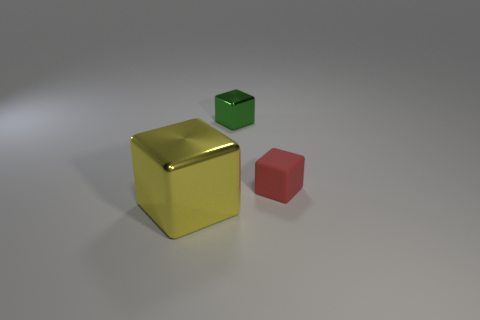Is there any other thing that has the same material as the red object?
Provide a short and direct response. No. What shape is the shiny object behind the object that is in front of the tiny red cube?
Give a very brief answer. Cube. The small metal object is what color?
Your answer should be compact. Green. Is there a tiny purple sphere?
Your answer should be very brief. No. There is a big yellow shiny object; are there any blocks behind it?
Your response must be concise. Yes. There is a red object that is the same shape as the yellow object; what material is it?
Make the answer very short. Rubber. How many other objects are the same shape as the small green object?
Make the answer very short. 2. There is a shiny cube that is left of the shiny object that is behind the red thing; what number of big yellow things are on the left side of it?
Your answer should be very brief. 0. What number of other big metallic objects are the same shape as the red object?
Your answer should be compact. 1. What shape is the metal thing in front of the metal thing that is behind the metallic block left of the green block?
Make the answer very short. Cube. 